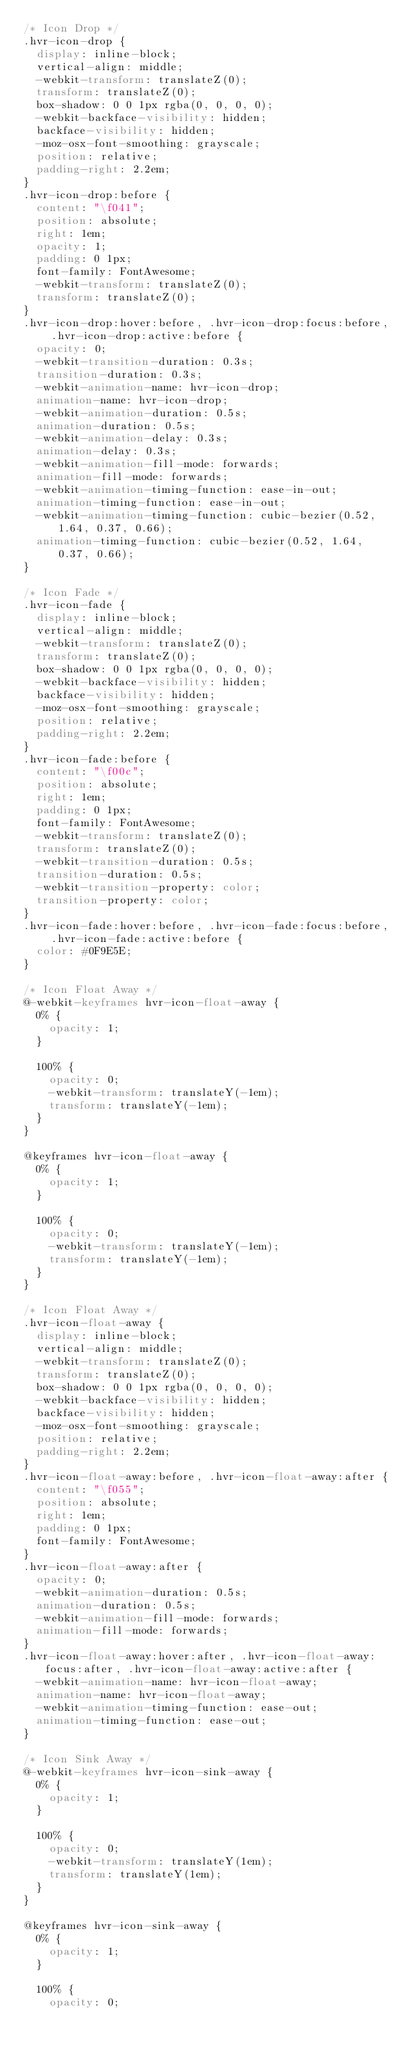<code> <loc_0><loc_0><loc_500><loc_500><_CSS_>/* Icon Drop */
.hvr-icon-drop {
  display: inline-block;
  vertical-align: middle;
  -webkit-transform: translateZ(0);
  transform: translateZ(0);
  box-shadow: 0 0 1px rgba(0, 0, 0, 0);
  -webkit-backface-visibility: hidden;
  backface-visibility: hidden;
  -moz-osx-font-smoothing: grayscale;
  position: relative;
  padding-right: 2.2em;
}
.hvr-icon-drop:before {
  content: "\f041";
  position: absolute;
  right: 1em;
  opacity: 1;
  padding: 0 1px;
  font-family: FontAwesome;
  -webkit-transform: translateZ(0);
  transform: translateZ(0);
}
.hvr-icon-drop:hover:before, .hvr-icon-drop:focus:before, .hvr-icon-drop:active:before {
  opacity: 0;
  -webkit-transition-duration: 0.3s;
  transition-duration: 0.3s;
  -webkit-animation-name: hvr-icon-drop;
  animation-name: hvr-icon-drop;
  -webkit-animation-duration: 0.5s;
  animation-duration: 0.5s;
  -webkit-animation-delay: 0.3s;
  animation-delay: 0.3s;
  -webkit-animation-fill-mode: forwards;
  animation-fill-mode: forwards;
  -webkit-animation-timing-function: ease-in-out;
  animation-timing-function: ease-in-out;
  -webkit-animation-timing-function: cubic-bezier(0.52, 1.64, 0.37, 0.66);
  animation-timing-function: cubic-bezier(0.52, 1.64, 0.37, 0.66);
}

/* Icon Fade */
.hvr-icon-fade {
  display: inline-block;
  vertical-align: middle;
  -webkit-transform: translateZ(0);
  transform: translateZ(0);
  box-shadow: 0 0 1px rgba(0, 0, 0, 0);
  -webkit-backface-visibility: hidden;
  backface-visibility: hidden;
  -moz-osx-font-smoothing: grayscale;
  position: relative;
  padding-right: 2.2em;
}
.hvr-icon-fade:before {
  content: "\f00c";
  position: absolute;
  right: 1em;
  padding: 0 1px;
  font-family: FontAwesome;
  -webkit-transform: translateZ(0);
  transform: translateZ(0);
  -webkit-transition-duration: 0.5s;
  transition-duration: 0.5s;
  -webkit-transition-property: color;
  transition-property: color;
}
.hvr-icon-fade:hover:before, .hvr-icon-fade:focus:before, .hvr-icon-fade:active:before {
  color: #0F9E5E;
}

/* Icon Float Away */
@-webkit-keyframes hvr-icon-float-away {
  0% {
    opacity: 1;
  }

  100% {
    opacity: 0;
    -webkit-transform: translateY(-1em);
    transform: translateY(-1em);
  }
}

@keyframes hvr-icon-float-away {
  0% {
    opacity: 1;
  }

  100% {
    opacity: 0;
    -webkit-transform: translateY(-1em);
    transform: translateY(-1em);
  }
}

/* Icon Float Away */
.hvr-icon-float-away {
  display: inline-block;
  vertical-align: middle;
  -webkit-transform: translateZ(0);
  transform: translateZ(0);
  box-shadow: 0 0 1px rgba(0, 0, 0, 0);
  -webkit-backface-visibility: hidden;
  backface-visibility: hidden;
  -moz-osx-font-smoothing: grayscale;
  position: relative;
  padding-right: 2.2em;
}
.hvr-icon-float-away:before, .hvr-icon-float-away:after {
  content: "\f055";
  position: absolute;
  right: 1em;
  padding: 0 1px;
  font-family: FontAwesome;
}
.hvr-icon-float-away:after {
  opacity: 0;
  -webkit-animation-duration: 0.5s;
  animation-duration: 0.5s;
  -webkit-animation-fill-mode: forwards;
  animation-fill-mode: forwards;
}
.hvr-icon-float-away:hover:after, .hvr-icon-float-away:focus:after, .hvr-icon-float-away:active:after {
  -webkit-animation-name: hvr-icon-float-away;
  animation-name: hvr-icon-float-away;
  -webkit-animation-timing-function: ease-out;
  animation-timing-function: ease-out;
}

/* Icon Sink Away */
@-webkit-keyframes hvr-icon-sink-away {
  0% {
    opacity: 1;
  }

  100% {
    opacity: 0;
    -webkit-transform: translateY(1em);
    transform: translateY(1em);
  }
}

@keyframes hvr-icon-sink-away {
  0% {
    opacity: 1;
  }

  100% {
    opacity: 0;</code> 